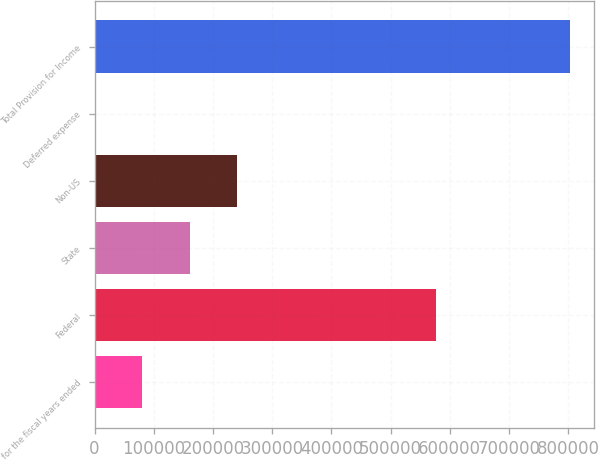Convert chart. <chart><loc_0><loc_0><loc_500><loc_500><bar_chart><fcel>for the fiscal years ended<fcel>Federal<fcel>State<fcel>Non-US<fcel>Deferred expense<fcel>Total Provision for Income<nl><fcel>80715<fcel>576418<fcel>161016<fcel>241317<fcel>414<fcel>803424<nl></chart> 